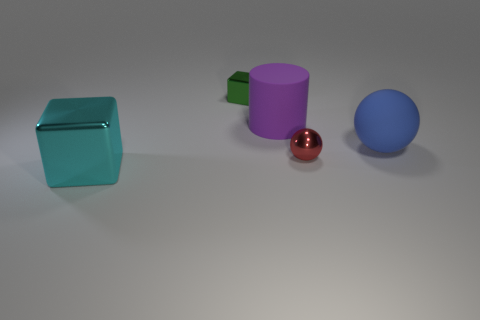What number of small green metallic cylinders are there?
Provide a succinct answer. 0. There is a tiny thing to the right of the shiny block that is behind the big cyan cube; what is its shape?
Your answer should be very brief. Sphere. What number of big things are behind the blue thing?
Offer a very short reply. 1. Does the large purple cylinder have the same material as the block that is on the left side of the tiny green metallic block?
Your response must be concise. No. Are there any matte spheres of the same size as the green block?
Offer a very short reply. No. Are there an equal number of tiny red metallic spheres that are to the left of the red thing and tiny brown objects?
Provide a short and direct response. Yes. The rubber ball is what size?
Offer a terse response. Large. There is a tiny shiny object right of the tiny green thing; how many small green metallic blocks are behind it?
Your answer should be compact. 1. There is a metallic object that is both in front of the green metal object and to the right of the big cyan metallic cube; what is its shape?
Provide a succinct answer. Sphere. What number of large blocks are the same color as the large rubber cylinder?
Offer a terse response. 0. 